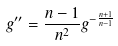<formula> <loc_0><loc_0><loc_500><loc_500>g ^ { \prime \prime } = \frac { n - 1 } { n ^ { 2 } } g ^ { - \frac { n + 1 } { n - 1 } }</formula> 